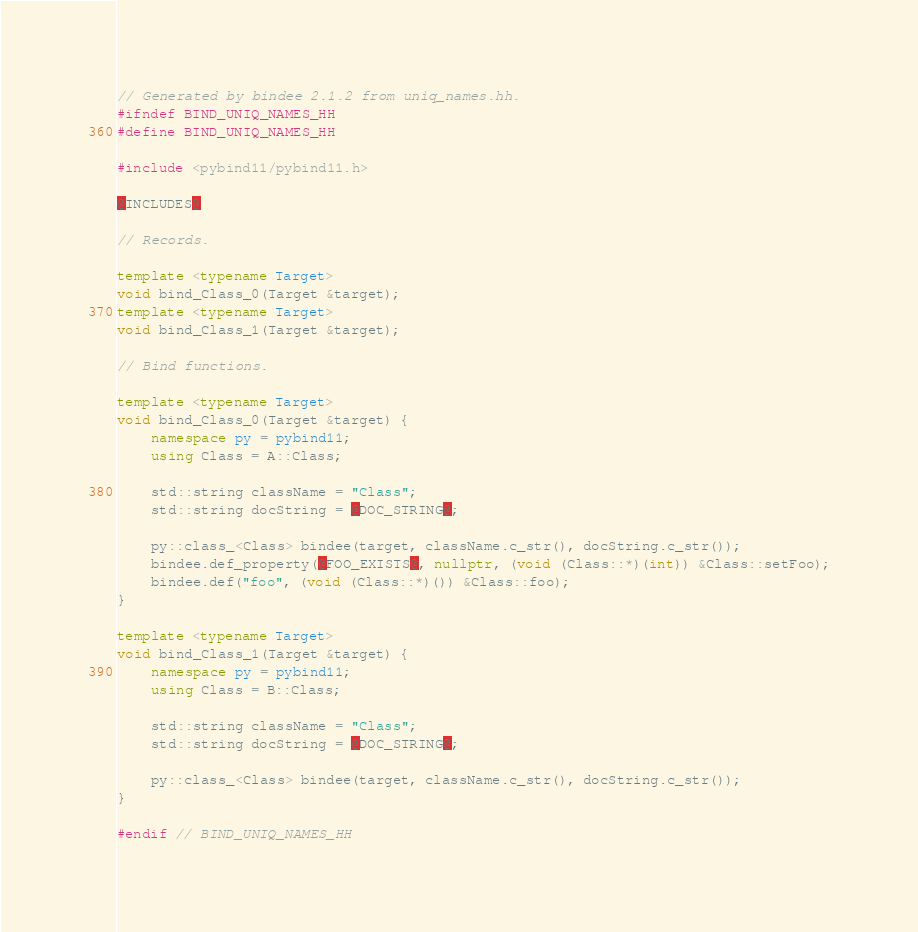<code> <loc_0><loc_0><loc_500><loc_500><_C++_>// Generated by bindee 2.1.2 from uniq_names.hh.
#ifndef BIND_UNIQ_NAMES_HH
#define BIND_UNIQ_NAMES_HH

#include <pybind11/pybind11.h>

@INCLUDES@

// Records.

template <typename Target>
void bind_Class_0(Target &target);
template <typename Target>
void bind_Class_1(Target &target);

// Bind functions.

template <typename Target>
void bind_Class_0(Target &target) {
    namespace py = pybind11;
    using Class = A::Class;

    std::string className = "Class";
    std::string docString = @DOC_STRING@;

    py::class_<Class> bindee(target, className.c_str(), docString.c_str());
    bindee.def_property(@FOO_EXISTS@, nullptr, (void (Class::*)(int)) &Class::setFoo);
    bindee.def("foo", (void (Class::*)()) &Class::foo);
}

template <typename Target>
void bind_Class_1(Target &target) {
    namespace py = pybind11;
    using Class = B::Class;

    std::string className = "Class";
    std::string docString = @DOC_STRING@;

    py::class_<Class> bindee(target, className.c_str(), docString.c_str());
}

#endif // BIND_UNIQ_NAMES_HH
</code> 